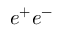<formula> <loc_0><loc_0><loc_500><loc_500>e ^ { + } e ^ { - }</formula> 